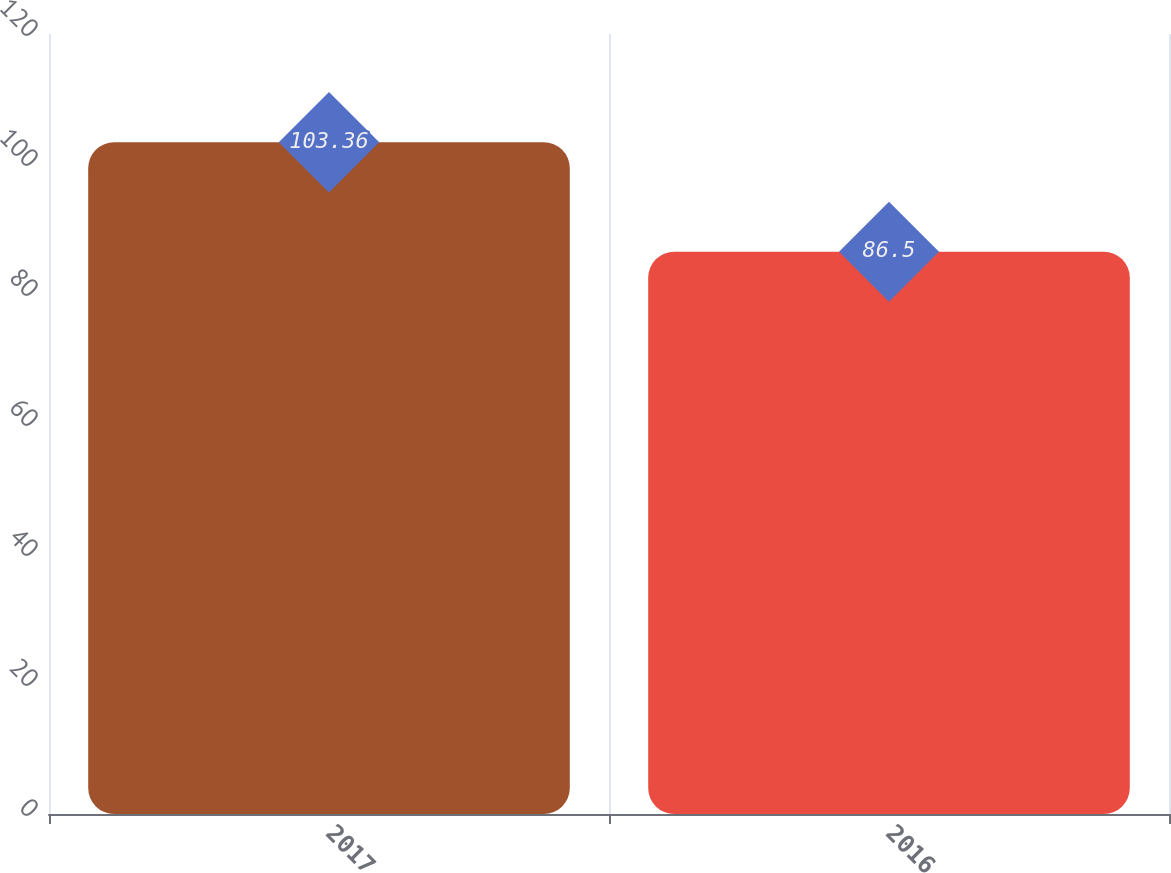<chart> <loc_0><loc_0><loc_500><loc_500><bar_chart><fcel>2017<fcel>2016<nl><fcel>103.36<fcel>86.5<nl></chart> 